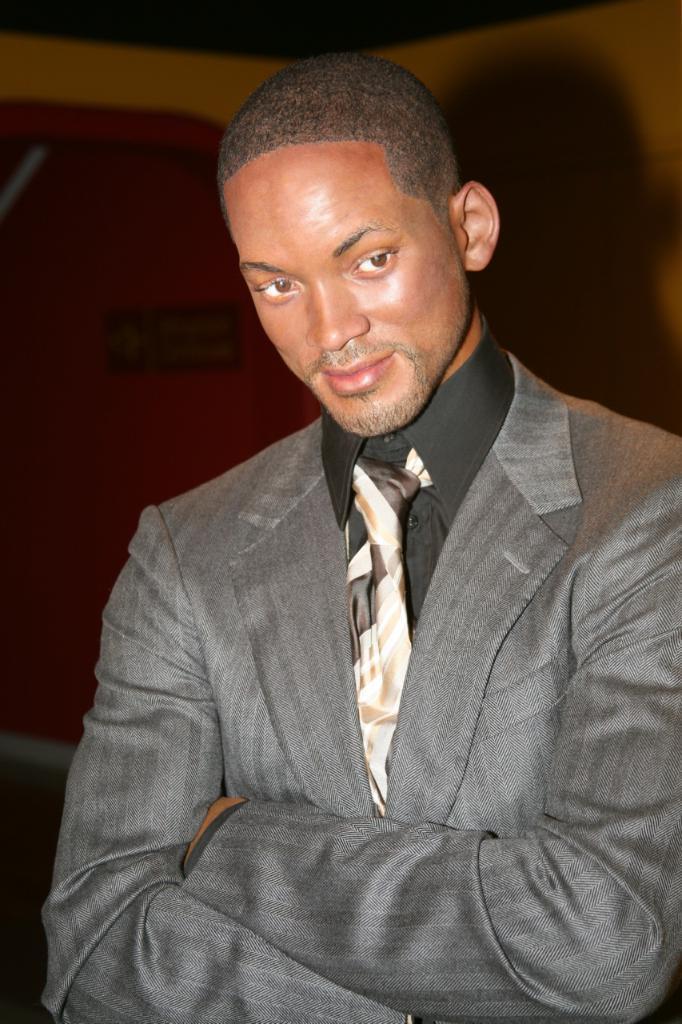In one or two sentences, can you explain what this image depicts? In this picture we can see a man, he is smiling. 